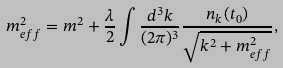<formula> <loc_0><loc_0><loc_500><loc_500>m _ { e f f } ^ { 2 } = m ^ { 2 } + \frac { \lambda } { 2 } \int \frac { d ^ { 3 } k } { ( 2 \pi ) ^ { 3 } } \frac { n _ { k } ( t _ { 0 } ) } { \sqrt { k ^ { 2 } + m _ { e f f } ^ { 2 } } } ,</formula> 